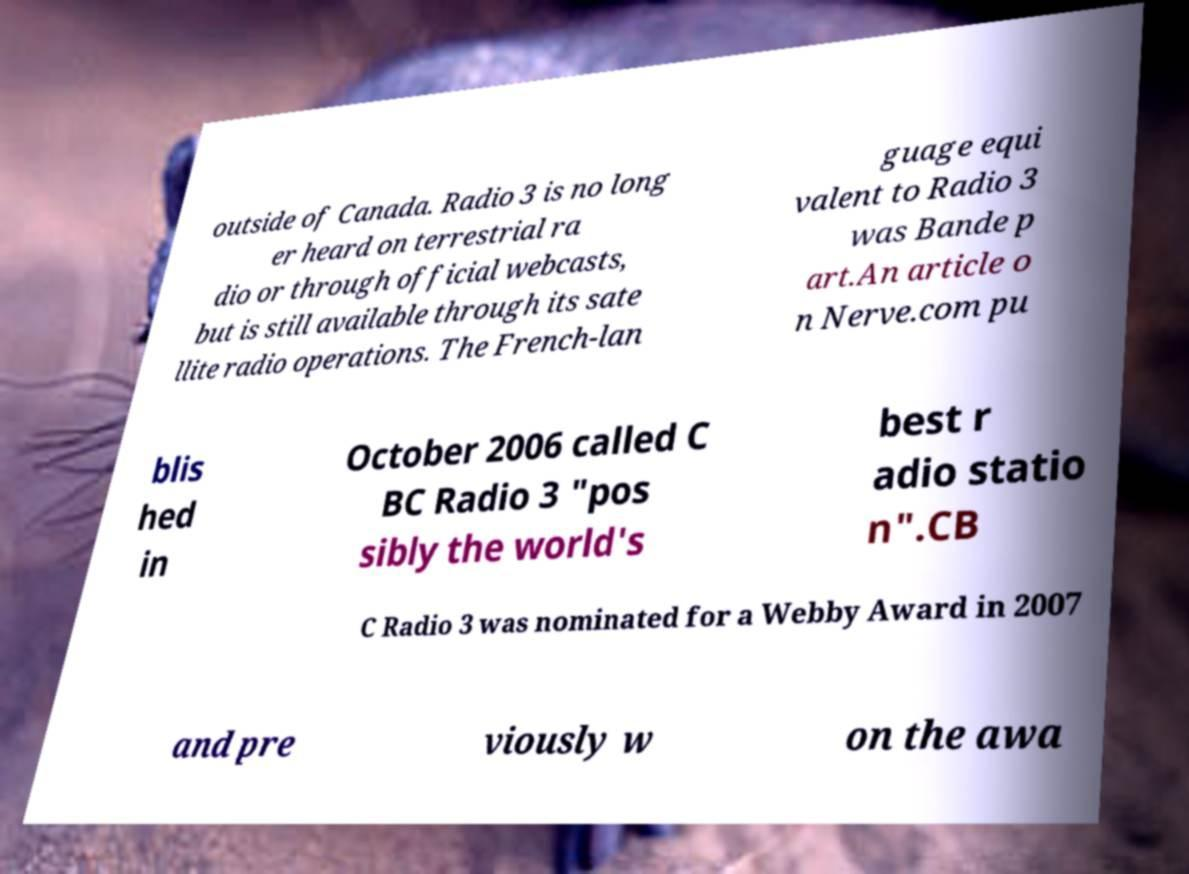Please read and relay the text visible in this image. What does it say? outside of Canada. Radio 3 is no long er heard on terrestrial ra dio or through official webcasts, but is still available through its sate llite radio operations. The French-lan guage equi valent to Radio 3 was Bande p art.An article o n Nerve.com pu blis hed in October 2006 called C BC Radio 3 "pos sibly the world's best r adio statio n".CB C Radio 3 was nominated for a Webby Award in 2007 and pre viously w on the awa 